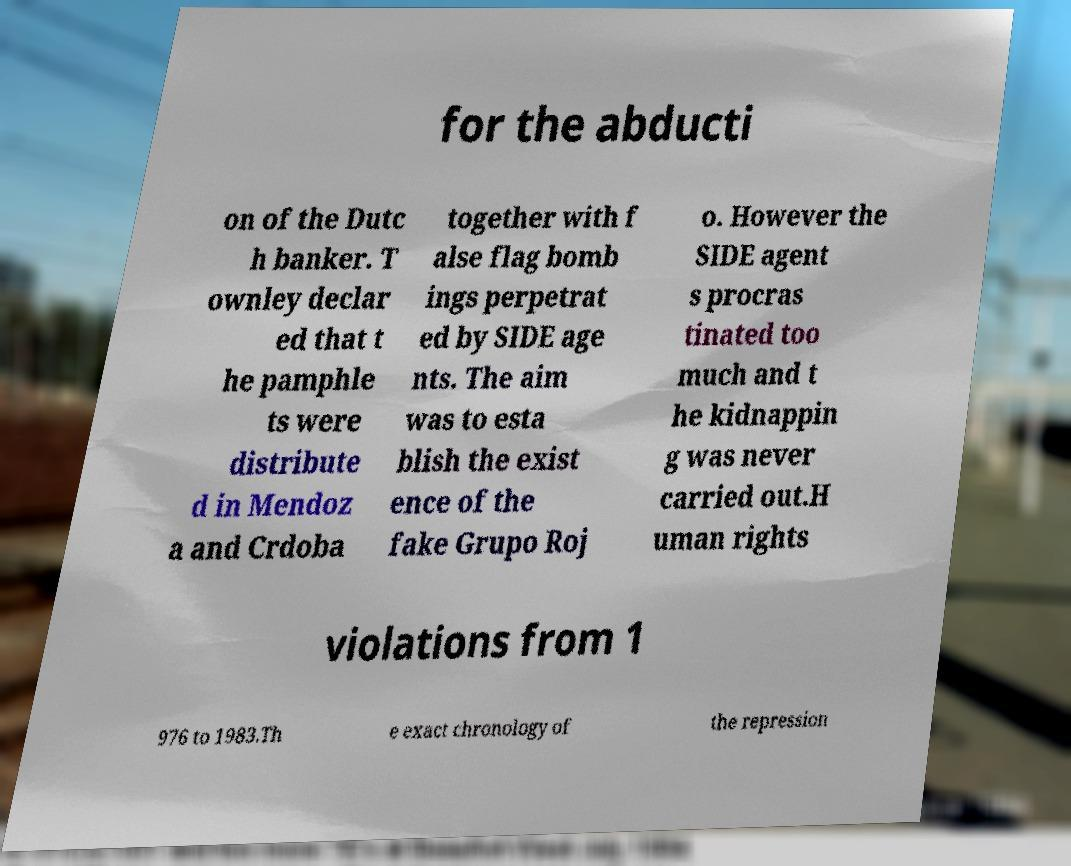Can you read and provide the text displayed in the image?This photo seems to have some interesting text. Can you extract and type it out for me? for the abducti on of the Dutc h banker. T ownley declar ed that t he pamphle ts were distribute d in Mendoz a and Crdoba together with f alse flag bomb ings perpetrat ed by SIDE age nts. The aim was to esta blish the exist ence of the fake Grupo Roj o. However the SIDE agent s procras tinated too much and t he kidnappin g was never carried out.H uman rights violations from 1 976 to 1983.Th e exact chronology of the repression 